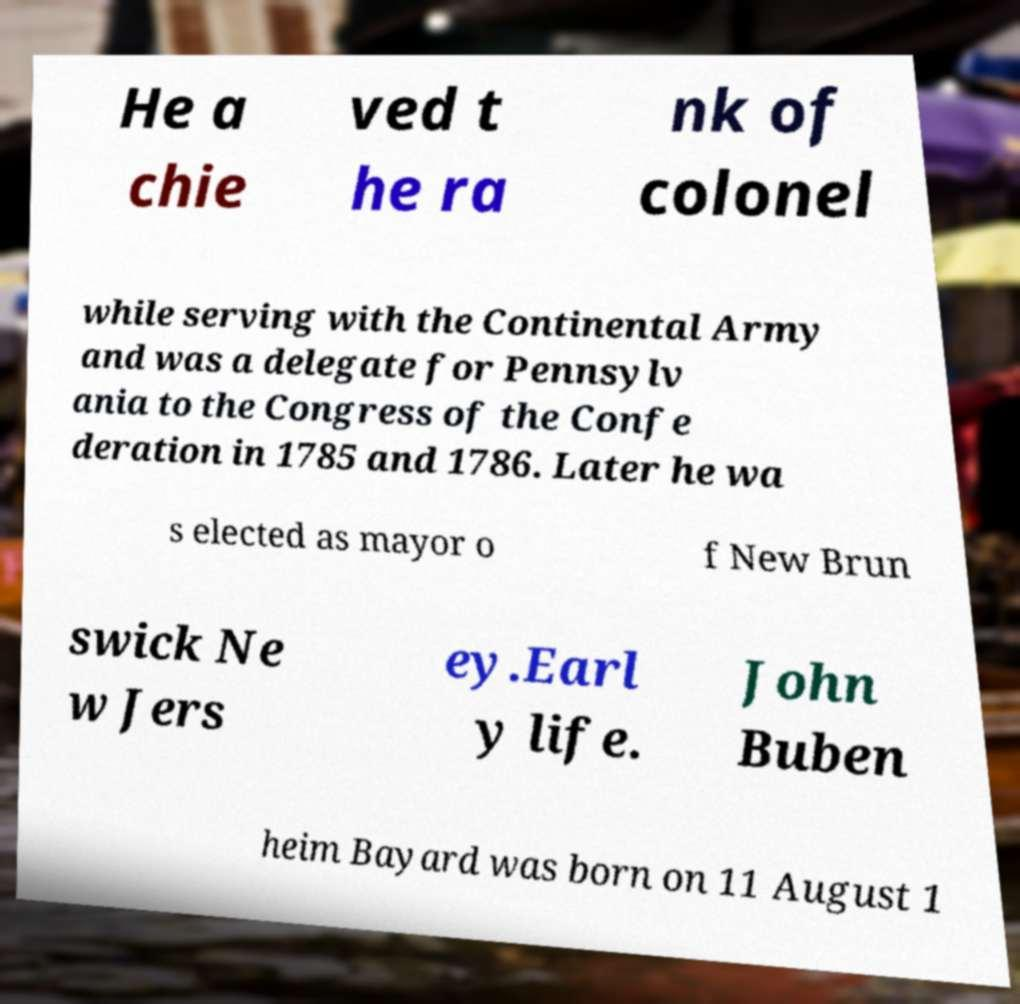Could you extract and type out the text from this image? He a chie ved t he ra nk of colonel while serving with the Continental Army and was a delegate for Pennsylv ania to the Congress of the Confe deration in 1785 and 1786. Later he wa s elected as mayor o f New Brun swick Ne w Jers ey.Earl y life. John Buben heim Bayard was born on 11 August 1 